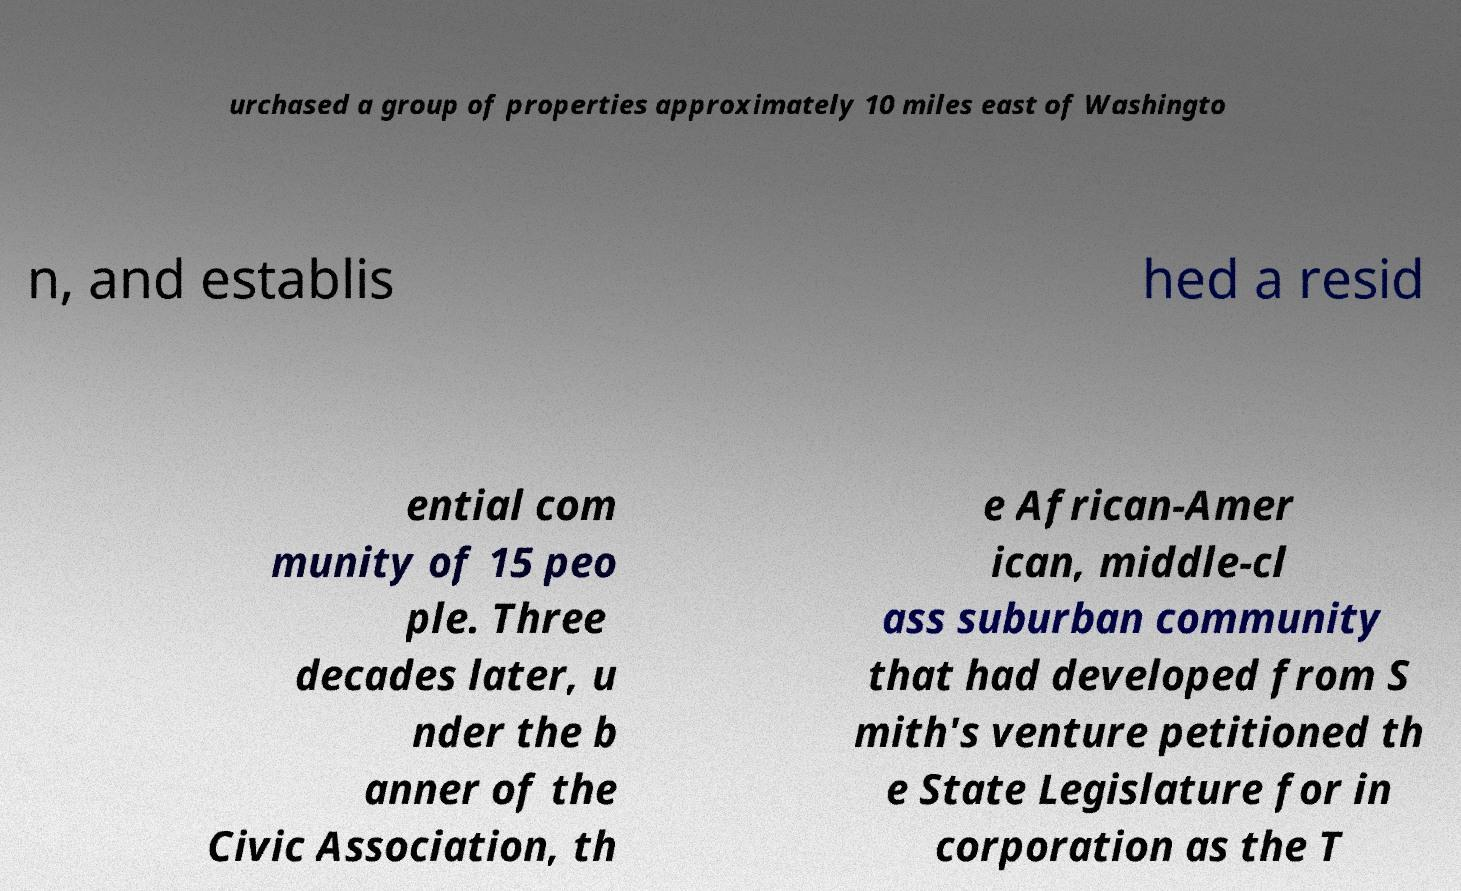Can you accurately transcribe the text from the provided image for me? urchased a group of properties approximately 10 miles east of Washingto n, and establis hed a resid ential com munity of 15 peo ple. Three decades later, u nder the b anner of the Civic Association, th e African-Amer ican, middle-cl ass suburban community that had developed from S mith's venture petitioned th e State Legislature for in corporation as the T 